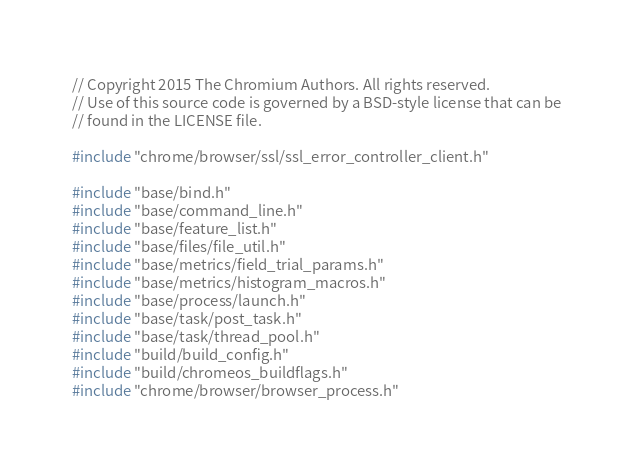Convert code to text. <code><loc_0><loc_0><loc_500><loc_500><_C++_>// Copyright 2015 The Chromium Authors. All rights reserved.
// Use of this source code is governed by a BSD-style license that can be
// found in the LICENSE file.

#include "chrome/browser/ssl/ssl_error_controller_client.h"

#include "base/bind.h"
#include "base/command_line.h"
#include "base/feature_list.h"
#include "base/files/file_util.h"
#include "base/metrics/field_trial_params.h"
#include "base/metrics/histogram_macros.h"
#include "base/process/launch.h"
#include "base/task/post_task.h"
#include "base/task/thread_pool.h"
#include "build/build_config.h"
#include "build/chromeos_buildflags.h"
#include "chrome/browser/browser_process.h"</code> 